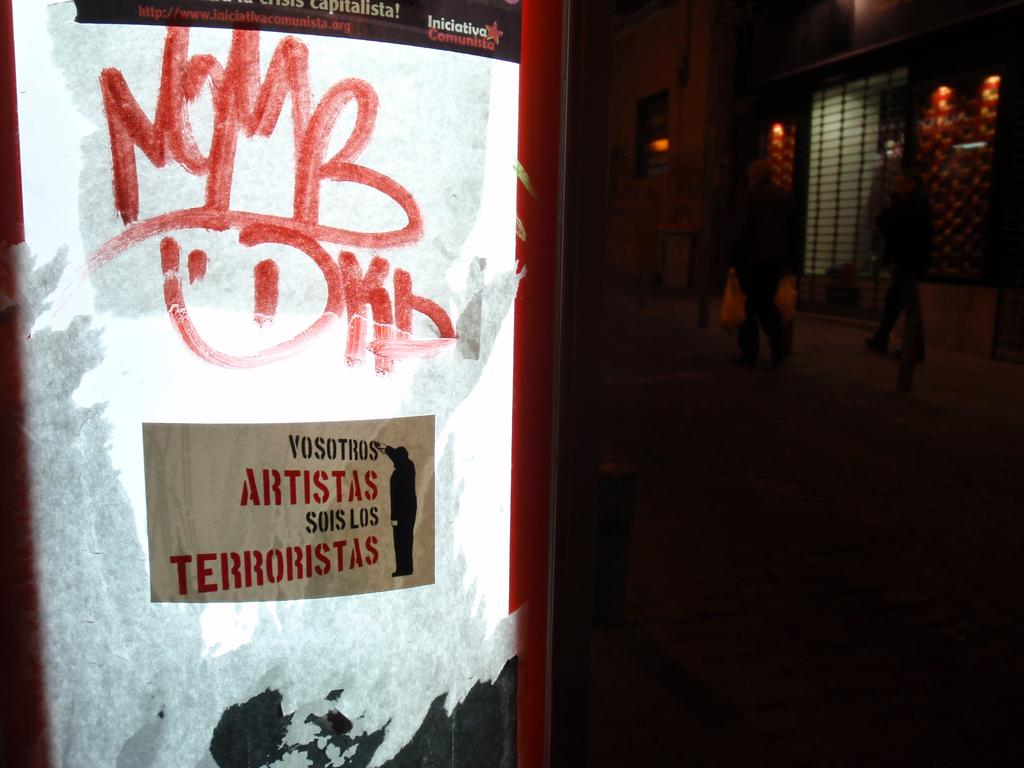<image>
Present a compact description of the photo's key features. An electronic sign that is sponsored by Iniciativa Comunista 